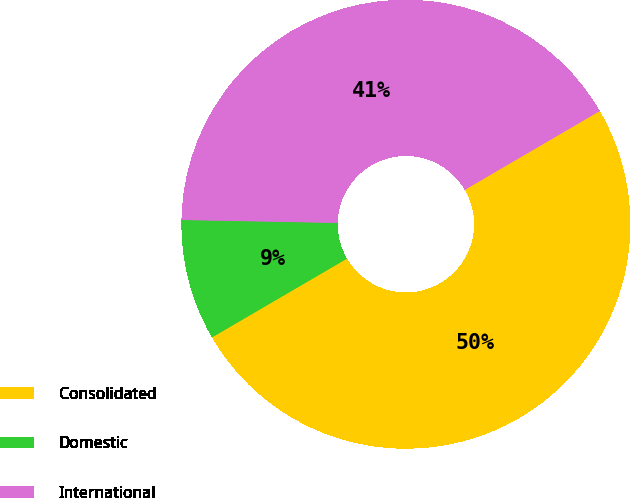Convert chart. <chart><loc_0><loc_0><loc_500><loc_500><pie_chart><fcel>Consolidated<fcel>Domestic<fcel>International<nl><fcel>50.0%<fcel>8.71%<fcel>41.29%<nl></chart> 